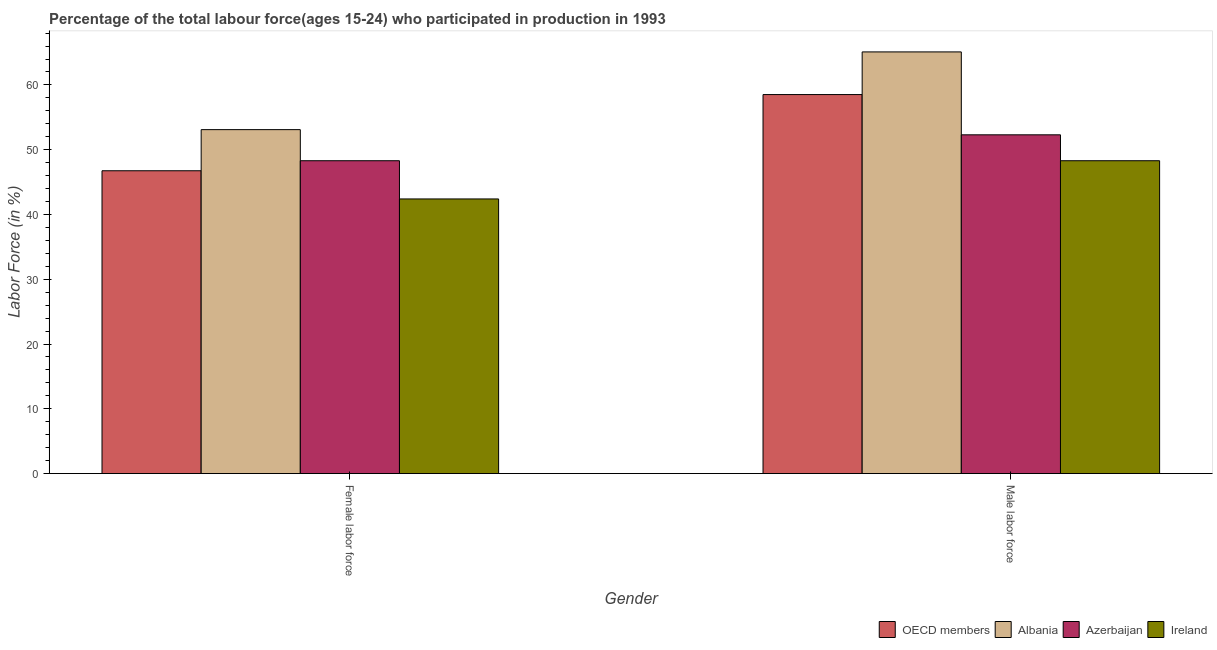How many different coloured bars are there?
Ensure brevity in your answer.  4. Are the number of bars per tick equal to the number of legend labels?
Give a very brief answer. Yes. Are the number of bars on each tick of the X-axis equal?
Provide a succinct answer. Yes. How many bars are there on the 2nd tick from the right?
Your response must be concise. 4. What is the label of the 2nd group of bars from the left?
Provide a succinct answer. Male labor force. What is the percentage of female labor force in OECD members?
Ensure brevity in your answer.  46.75. Across all countries, what is the maximum percentage of female labor force?
Your answer should be very brief. 53.1. Across all countries, what is the minimum percentage of female labor force?
Your response must be concise. 42.4. In which country was the percentage of female labor force maximum?
Provide a succinct answer. Albania. In which country was the percentage of female labor force minimum?
Your answer should be compact. Ireland. What is the total percentage of female labor force in the graph?
Ensure brevity in your answer.  190.55. What is the difference between the percentage of male labour force in Ireland and that in OECD members?
Offer a very short reply. -10.21. What is the difference between the percentage of female labor force in Albania and the percentage of male labour force in OECD members?
Offer a very short reply. -5.41. What is the average percentage of male labour force per country?
Keep it short and to the point. 56.05. What is the difference between the percentage of male labour force and percentage of female labor force in Albania?
Your answer should be compact. 12. In how many countries, is the percentage of male labour force greater than 66 %?
Offer a terse response. 0. What is the ratio of the percentage of male labour force in OECD members to that in Ireland?
Offer a very short reply. 1.21. Is the percentage of female labor force in Albania less than that in Azerbaijan?
Your answer should be compact. No. In how many countries, is the percentage of female labor force greater than the average percentage of female labor force taken over all countries?
Your response must be concise. 2. What does the 3rd bar from the left in Male labor force represents?
Offer a very short reply. Azerbaijan. What does the 3rd bar from the right in Male labor force represents?
Your response must be concise. Albania. Are all the bars in the graph horizontal?
Provide a succinct answer. No. How many countries are there in the graph?
Provide a short and direct response. 4. What is the difference between two consecutive major ticks on the Y-axis?
Give a very brief answer. 10. Are the values on the major ticks of Y-axis written in scientific E-notation?
Offer a terse response. No. Does the graph contain any zero values?
Give a very brief answer. No. How are the legend labels stacked?
Ensure brevity in your answer.  Horizontal. What is the title of the graph?
Make the answer very short. Percentage of the total labour force(ages 15-24) who participated in production in 1993. Does "High income: OECD" appear as one of the legend labels in the graph?
Offer a terse response. No. What is the label or title of the X-axis?
Make the answer very short. Gender. What is the label or title of the Y-axis?
Your response must be concise. Labor Force (in %). What is the Labor Force (in %) in OECD members in Female labor force?
Your response must be concise. 46.75. What is the Labor Force (in %) in Albania in Female labor force?
Your answer should be very brief. 53.1. What is the Labor Force (in %) of Azerbaijan in Female labor force?
Make the answer very short. 48.3. What is the Labor Force (in %) in Ireland in Female labor force?
Give a very brief answer. 42.4. What is the Labor Force (in %) of OECD members in Male labor force?
Ensure brevity in your answer.  58.51. What is the Labor Force (in %) of Albania in Male labor force?
Ensure brevity in your answer.  65.1. What is the Labor Force (in %) in Azerbaijan in Male labor force?
Your answer should be very brief. 52.3. What is the Labor Force (in %) of Ireland in Male labor force?
Provide a succinct answer. 48.3. Across all Gender, what is the maximum Labor Force (in %) of OECD members?
Ensure brevity in your answer.  58.51. Across all Gender, what is the maximum Labor Force (in %) in Albania?
Provide a succinct answer. 65.1. Across all Gender, what is the maximum Labor Force (in %) in Azerbaijan?
Provide a succinct answer. 52.3. Across all Gender, what is the maximum Labor Force (in %) in Ireland?
Your answer should be compact. 48.3. Across all Gender, what is the minimum Labor Force (in %) of OECD members?
Your response must be concise. 46.75. Across all Gender, what is the minimum Labor Force (in %) of Albania?
Provide a short and direct response. 53.1. Across all Gender, what is the minimum Labor Force (in %) in Azerbaijan?
Make the answer very short. 48.3. Across all Gender, what is the minimum Labor Force (in %) of Ireland?
Make the answer very short. 42.4. What is the total Labor Force (in %) of OECD members in the graph?
Provide a succinct answer. 105.26. What is the total Labor Force (in %) in Albania in the graph?
Keep it short and to the point. 118.2. What is the total Labor Force (in %) in Azerbaijan in the graph?
Provide a succinct answer. 100.6. What is the total Labor Force (in %) in Ireland in the graph?
Ensure brevity in your answer.  90.7. What is the difference between the Labor Force (in %) of OECD members in Female labor force and that in Male labor force?
Give a very brief answer. -11.76. What is the difference between the Labor Force (in %) in Azerbaijan in Female labor force and that in Male labor force?
Your response must be concise. -4. What is the difference between the Labor Force (in %) in Ireland in Female labor force and that in Male labor force?
Your answer should be very brief. -5.9. What is the difference between the Labor Force (in %) in OECD members in Female labor force and the Labor Force (in %) in Albania in Male labor force?
Provide a short and direct response. -18.35. What is the difference between the Labor Force (in %) of OECD members in Female labor force and the Labor Force (in %) of Azerbaijan in Male labor force?
Keep it short and to the point. -5.55. What is the difference between the Labor Force (in %) in OECD members in Female labor force and the Labor Force (in %) in Ireland in Male labor force?
Give a very brief answer. -1.55. What is the difference between the Labor Force (in %) of Albania in Female labor force and the Labor Force (in %) of Azerbaijan in Male labor force?
Give a very brief answer. 0.8. What is the difference between the Labor Force (in %) of Azerbaijan in Female labor force and the Labor Force (in %) of Ireland in Male labor force?
Keep it short and to the point. 0. What is the average Labor Force (in %) in OECD members per Gender?
Provide a short and direct response. 52.63. What is the average Labor Force (in %) in Albania per Gender?
Keep it short and to the point. 59.1. What is the average Labor Force (in %) of Azerbaijan per Gender?
Your answer should be very brief. 50.3. What is the average Labor Force (in %) of Ireland per Gender?
Provide a short and direct response. 45.35. What is the difference between the Labor Force (in %) of OECD members and Labor Force (in %) of Albania in Female labor force?
Offer a terse response. -6.35. What is the difference between the Labor Force (in %) in OECD members and Labor Force (in %) in Azerbaijan in Female labor force?
Your answer should be compact. -1.55. What is the difference between the Labor Force (in %) of OECD members and Labor Force (in %) of Ireland in Female labor force?
Offer a terse response. 4.35. What is the difference between the Labor Force (in %) of Albania and Labor Force (in %) of Azerbaijan in Female labor force?
Keep it short and to the point. 4.8. What is the difference between the Labor Force (in %) in Azerbaijan and Labor Force (in %) in Ireland in Female labor force?
Offer a terse response. 5.9. What is the difference between the Labor Force (in %) in OECD members and Labor Force (in %) in Albania in Male labor force?
Provide a succinct answer. -6.59. What is the difference between the Labor Force (in %) of OECD members and Labor Force (in %) of Azerbaijan in Male labor force?
Provide a short and direct response. 6.21. What is the difference between the Labor Force (in %) of OECD members and Labor Force (in %) of Ireland in Male labor force?
Your response must be concise. 10.21. What is the difference between the Labor Force (in %) in Albania and Labor Force (in %) in Ireland in Male labor force?
Offer a very short reply. 16.8. What is the ratio of the Labor Force (in %) of OECD members in Female labor force to that in Male labor force?
Provide a succinct answer. 0.8. What is the ratio of the Labor Force (in %) of Albania in Female labor force to that in Male labor force?
Provide a succinct answer. 0.82. What is the ratio of the Labor Force (in %) in Azerbaijan in Female labor force to that in Male labor force?
Your answer should be compact. 0.92. What is the ratio of the Labor Force (in %) in Ireland in Female labor force to that in Male labor force?
Provide a succinct answer. 0.88. What is the difference between the highest and the second highest Labor Force (in %) in OECD members?
Your answer should be very brief. 11.76. What is the difference between the highest and the second highest Labor Force (in %) of Albania?
Keep it short and to the point. 12. What is the difference between the highest and the second highest Labor Force (in %) of Ireland?
Provide a short and direct response. 5.9. What is the difference between the highest and the lowest Labor Force (in %) in OECD members?
Your answer should be very brief. 11.76. What is the difference between the highest and the lowest Labor Force (in %) of Albania?
Provide a short and direct response. 12. What is the difference between the highest and the lowest Labor Force (in %) of Ireland?
Provide a short and direct response. 5.9. 